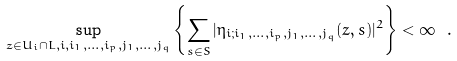<formula> <loc_0><loc_0><loc_500><loc_500>\sup _ { z \in U _ { i } \cap L , i , i _ { 1 } , \dots , i _ { p } , j _ { 1 } , \dots , j _ { q } } \left \{ \sum _ { s \in S } | \eta _ { i ; i _ { 1 } , \dots , i _ { p } , j _ { 1 } , \dots , j _ { q } } ( z , s ) | ^ { 2 } \right \} < \infty \ .</formula> 